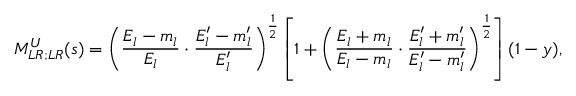Convert formula to latex. <formula><loc_0><loc_0><loc_500><loc_500>M _ { L R ; L R } ^ { U } ( s ) = \left ( \frac { E _ { l } - m _ { l } } { E _ { l } } \cdot \frac { E _ { l } ^ { \prime } - m _ { l } ^ { \prime } } { E _ { l } ^ { \prime } } \right ) ^ { \frac { 1 } { 2 } } \left [ 1 + \left ( \frac { E _ { l } + m _ { l } } { E _ { l } - m _ { l } } \cdot \frac { E _ { l } ^ { \prime } + m _ { l } ^ { \prime } } { E _ { l } ^ { \prime } - m _ { l } ^ { \prime } } \right ) ^ { \frac { 1 } { 2 } } \right ] ( 1 - y ) ,</formula> 